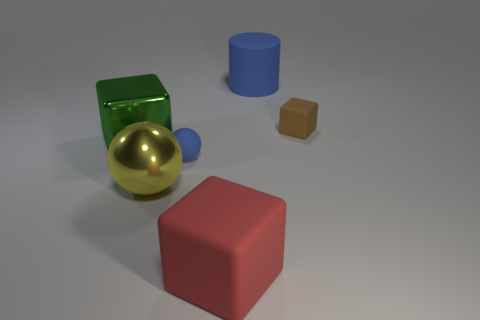What number of small objects are red objects or blue blocks?
Your answer should be compact. 0. What size is the cylinder?
Offer a terse response. Large. Is the number of balls that are right of the cylinder greater than the number of large blocks?
Give a very brief answer. No. Are there the same number of blue things that are to the right of the big blue rubber cylinder and red objects that are behind the red object?
Ensure brevity in your answer.  Yes. The big thing that is both to the left of the red cube and behind the big metal sphere is what color?
Your answer should be very brief. Green. Are there any other things that are the same size as the matte cylinder?
Make the answer very short. Yes. Are there more large shiny things on the right side of the tiny sphere than tiny cubes left of the red object?
Offer a very short reply. No. Is the size of the blue matte object that is behind the brown cube the same as the big green shiny block?
Provide a succinct answer. Yes. There is a blue rubber object to the left of the matte cube in front of the small brown matte cube; how many metallic things are on the right side of it?
Keep it short and to the point. 0. There is a cube that is to the right of the yellow metal sphere and on the left side of the small cube; how big is it?
Your answer should be very brief. Large. 